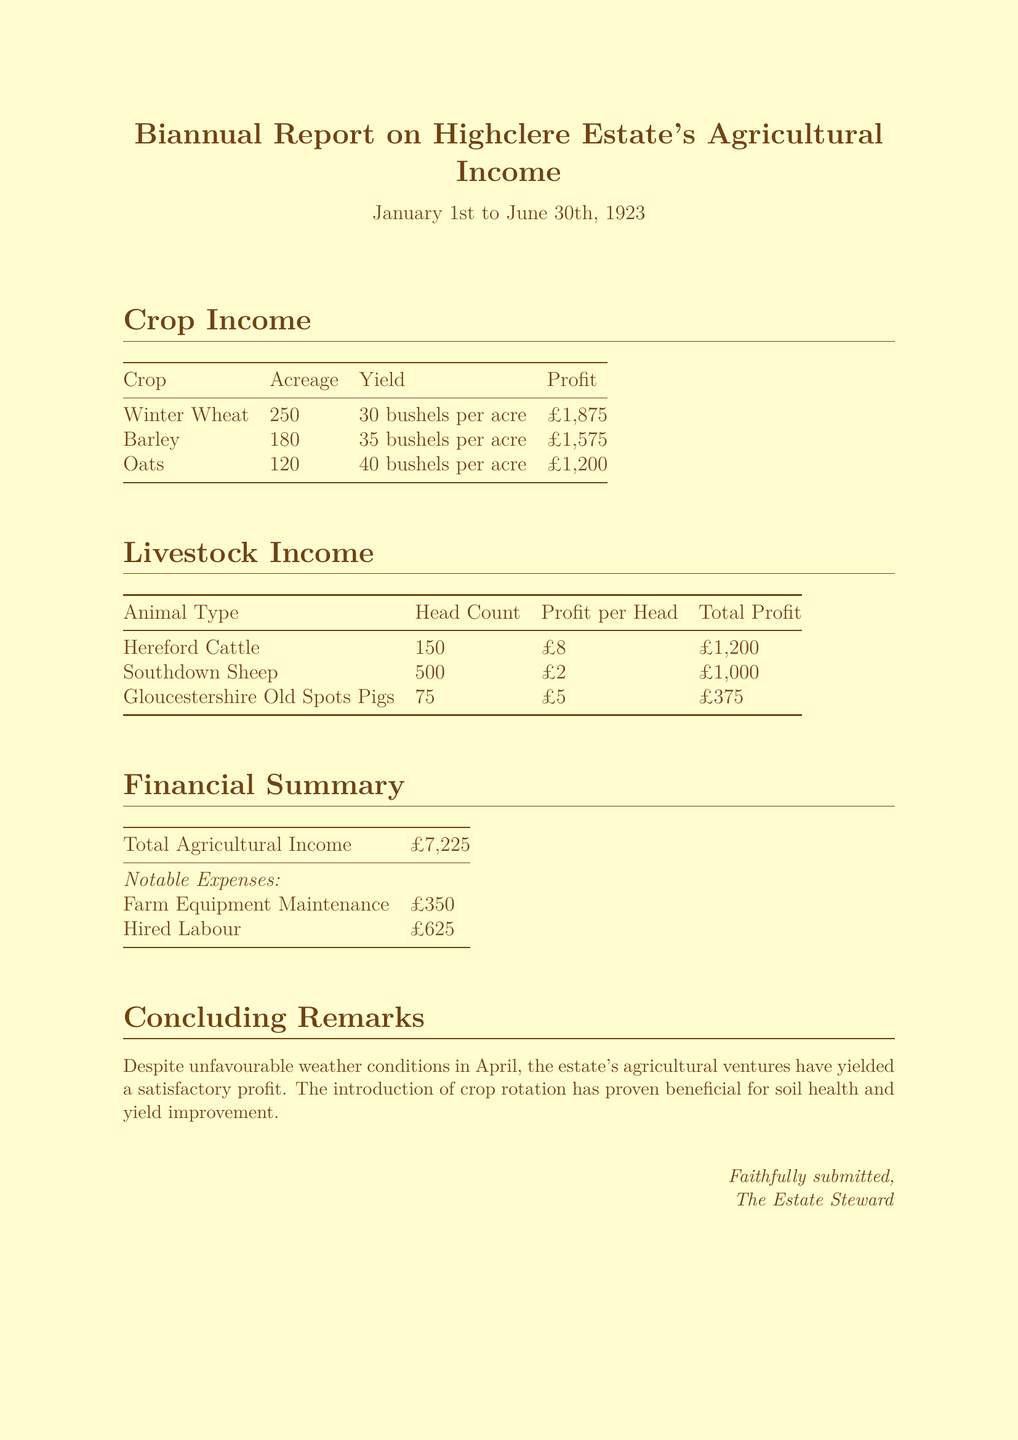What is the total agricultural income? The total agricultural income is a summary figure that consolidates all sources of income reported, amounting to £7,225.
Answer: £7,225 How many acres of Winter Wheat were planted? The acreage information for Winter Wheat is specified as part of the crop income section.
Answer: 250 What was the profit per head for Southdown Sheep? The profit per head for Southdown Sheep can be found in the livestock income section of the report.
Answer: £2 What notable expense incurred the highest amount? The notable expenses listed include Farm Equipment Maintenance and Hired Labour; Hired Labour has the greater amount at £625.
Answer: Hired Labour What was the yield of Barley per acre? The yield of Barley per acre is specified under the crop income section, giving a clear quantity for Barley.
Answer: 35 bushels per acre How many Hereford Cattle are reported? The head count of Hereford Cattle is a specific quantity mentioned in the livestock income table.
Answer: 150 What is mentioned as beneficial for soil health? The concluding remarks highlight the introduction of crop rotation as being beneficial for soil health and yield improvement.
Answer: Crop rotation What was the total profit from Oats? The total profit from Oats is explicitly stated in the crop income section of the report.
Answer: £1,200 